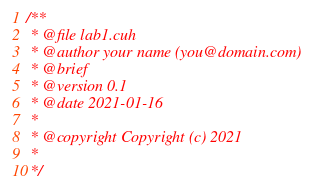Convert code to text. <code><loc_0><loc_0><loc_500><loc_500><_Cuda_>/**
 * @file lab1.cuh
 * @author your name (you@domain.com)
 * @brief 
 * @version 0.1
 * @date 2021-01-16
 * 
 * @copyright Copyright (c) 2021
 * 
 */
</code> 